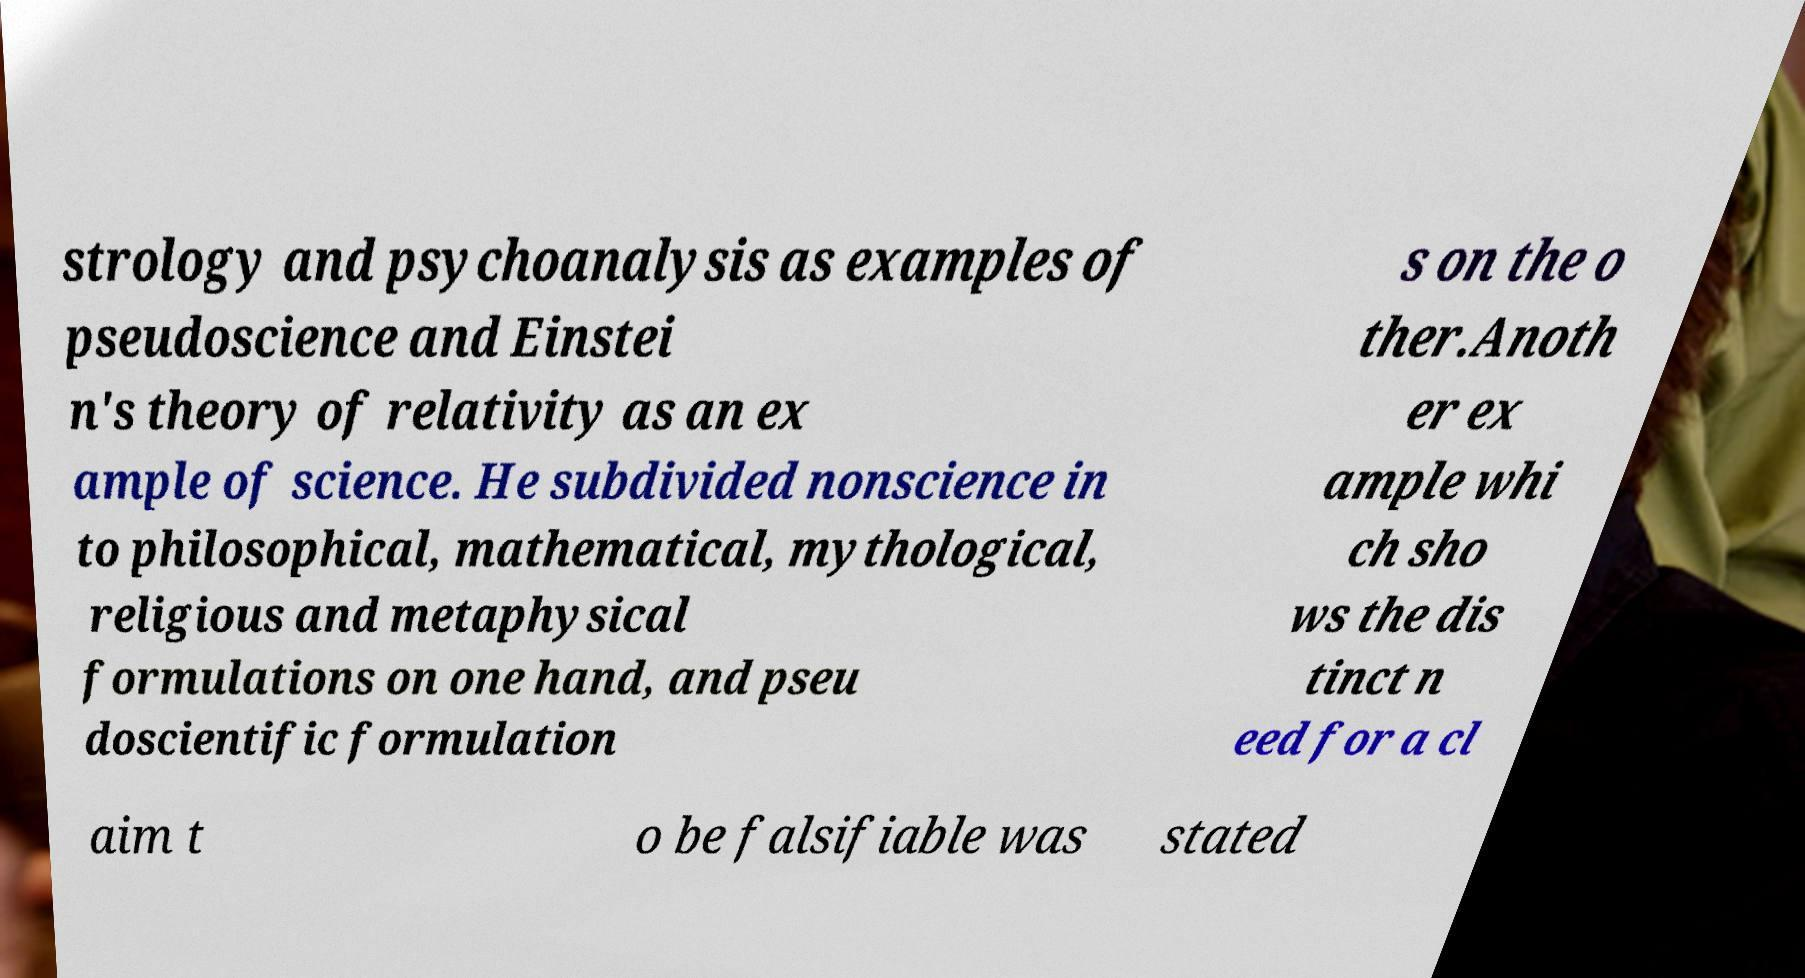Please read and relay the text visible in this image. What does it say? strology and psychoanalysis as examples of pseudoscience and Einstei n's theory of relativity as an ex ample of science. He subdivided nonscience in to philosophical, mathematical, mythological, religious and metaphysical formulations on one hand, and pseu doscientific formulation s on the o ther.Anoth er ex ample whi ch sho ws the dis tinct n eed for a cl aim t o be falsifiable was stated 